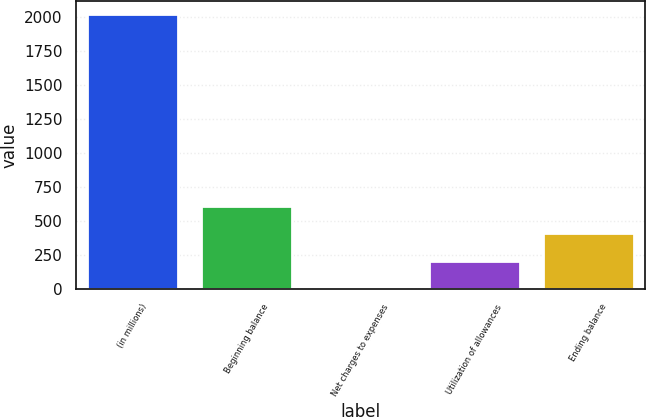Convert chart to OTSL. <chart><loc_0><loc_0><loc_500><loc_500><bar_chart><fcel>(in millions)<fcel>Beginning balance<fcel>Net charges to expenses<fcel>Utilization of allowances<fcel>Ending balance<nl><fcel>2016<fcel>611.1<fcel>9<fcel>209.7<fcel>410.4<nl></chart> 